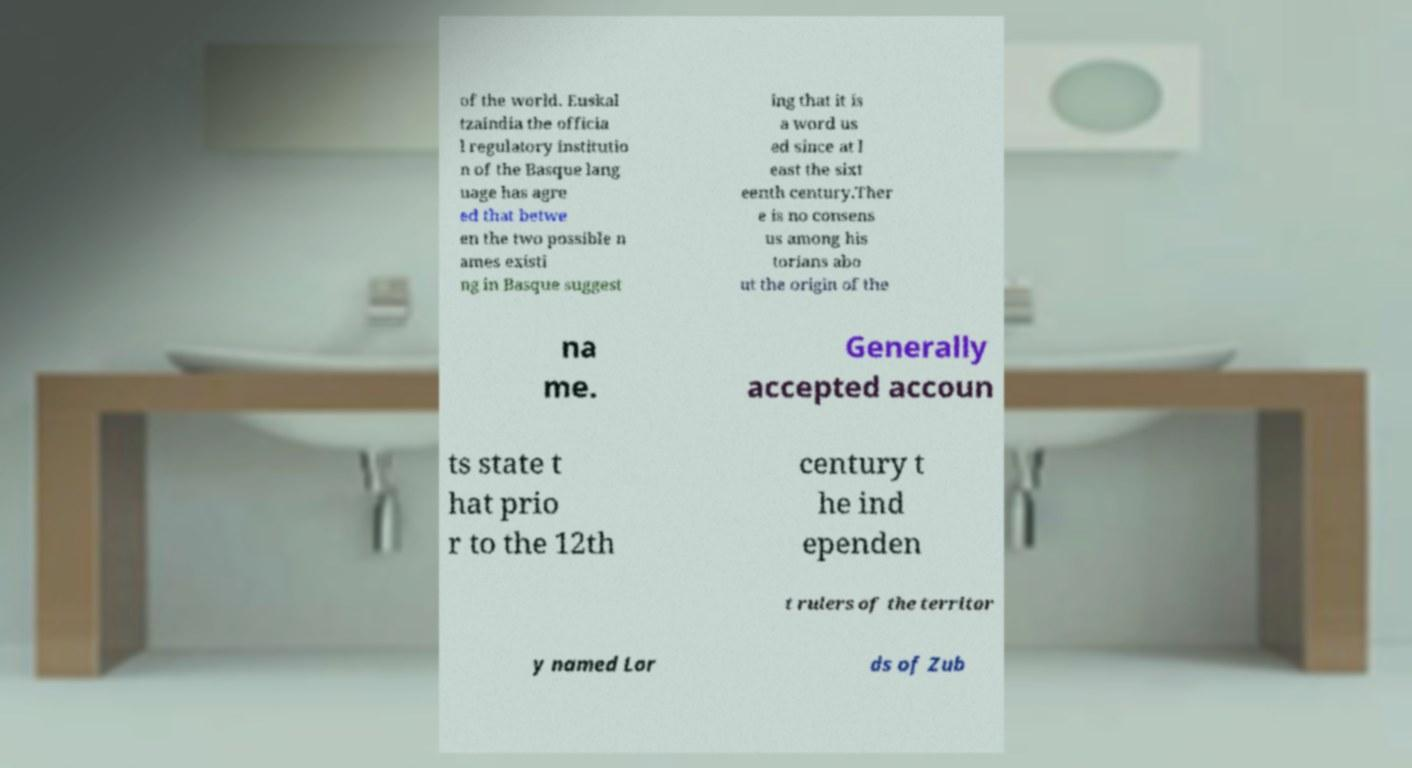What messages or text are displayed in this image? I need them in a readable, typed format. of the world. Euskal tzaindia the officia l regulatory institutio n of the Basque lang uage has agre ed that betwe en the two possible n ames existi ng in Basque suggest ing that it is a word us ed since at l east the sixt eenth century.Ther e is no consens us among his torians abo ut the origin of the na me. Generally accepted accoun ts state t hat prio r to the 12th century t he ind ependen t rulers of the territor y named Lor ds of Zub 